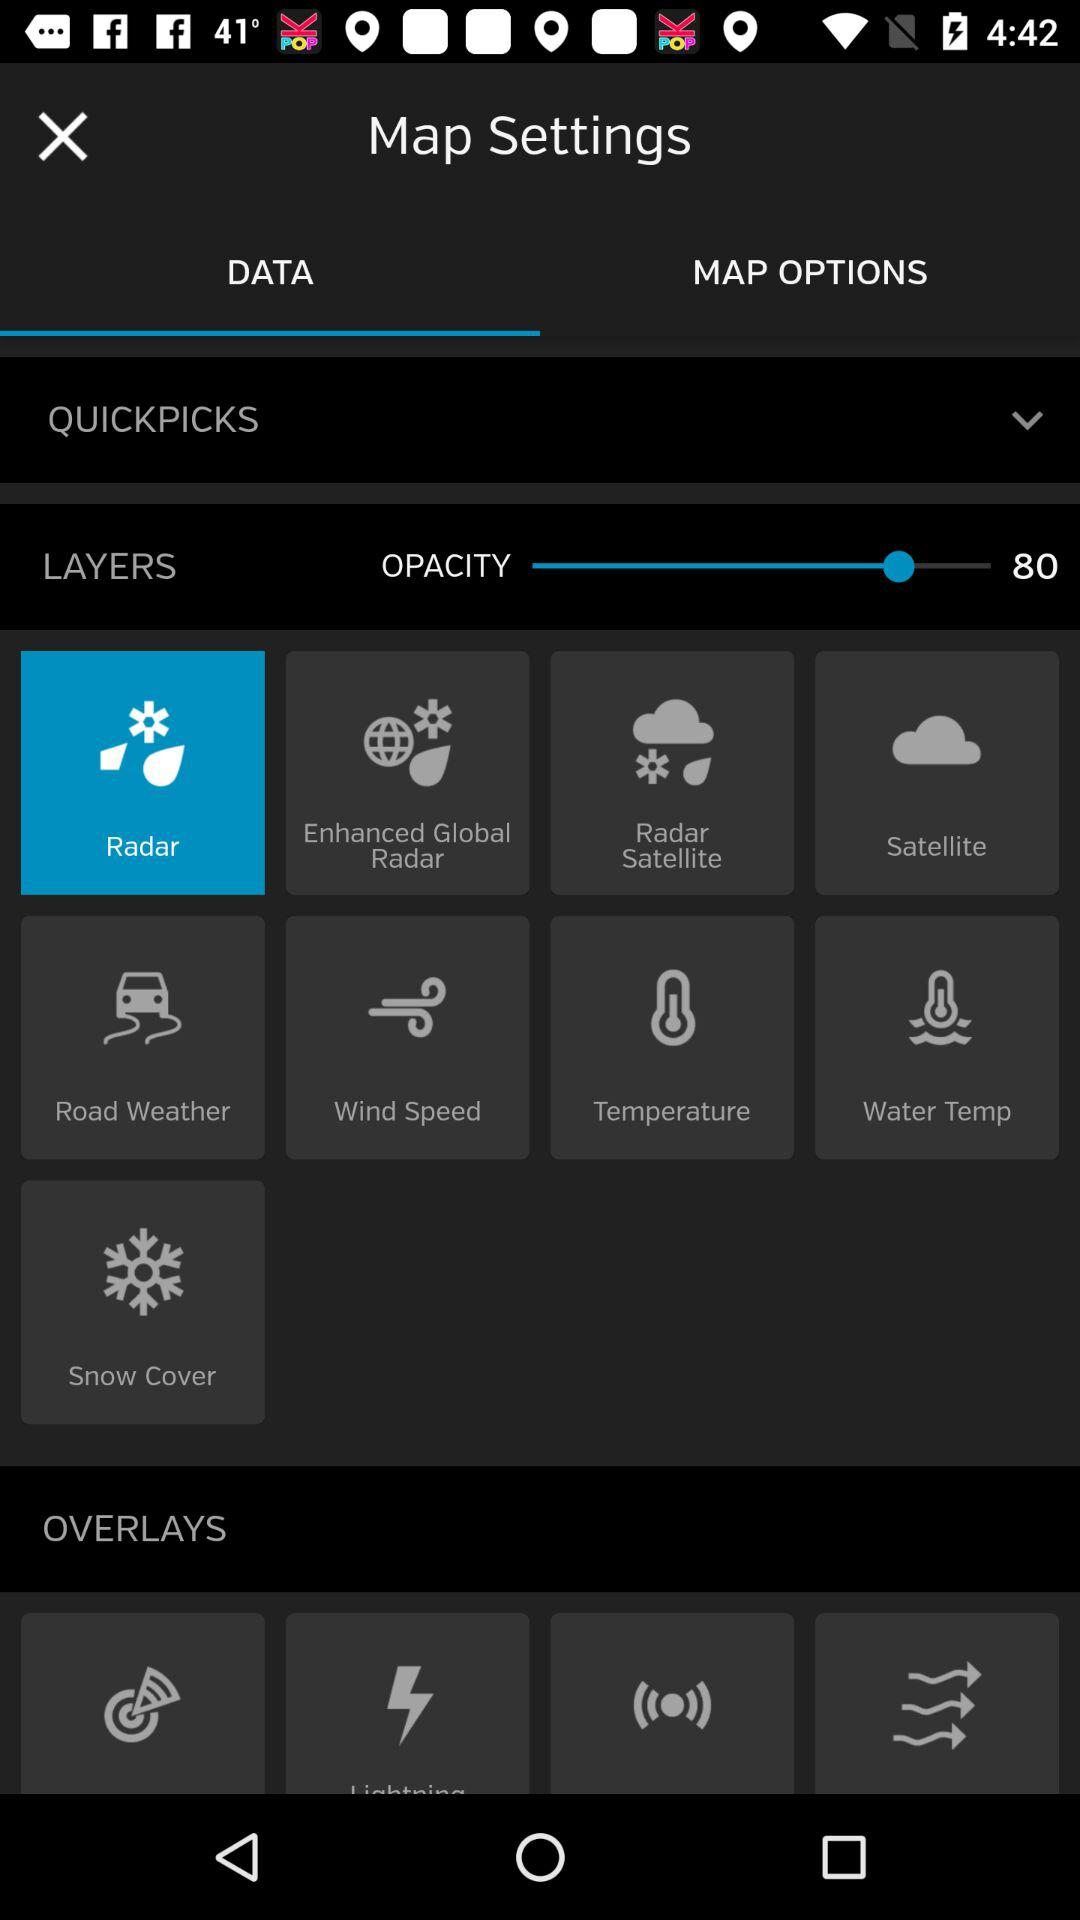Which layer is currently active?
When the provided information is insufficient, respond with <no answer>. <no answer> 